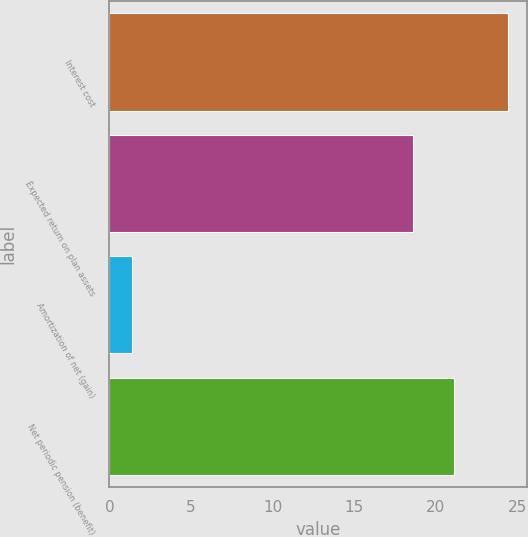Convert chart to OTSL. <chart><loc_0><loc_0><loc_500><loc_500><bar_chart><fcel>Interest cost<fcel>Expected return on plan assets<fcel>Amortization of net (gain)<fcel>Net periodic pension (benefit)<nl><fcel>24.4<fcel>18.6<fcel>1.4<fcel>21.1<nl></chart> 